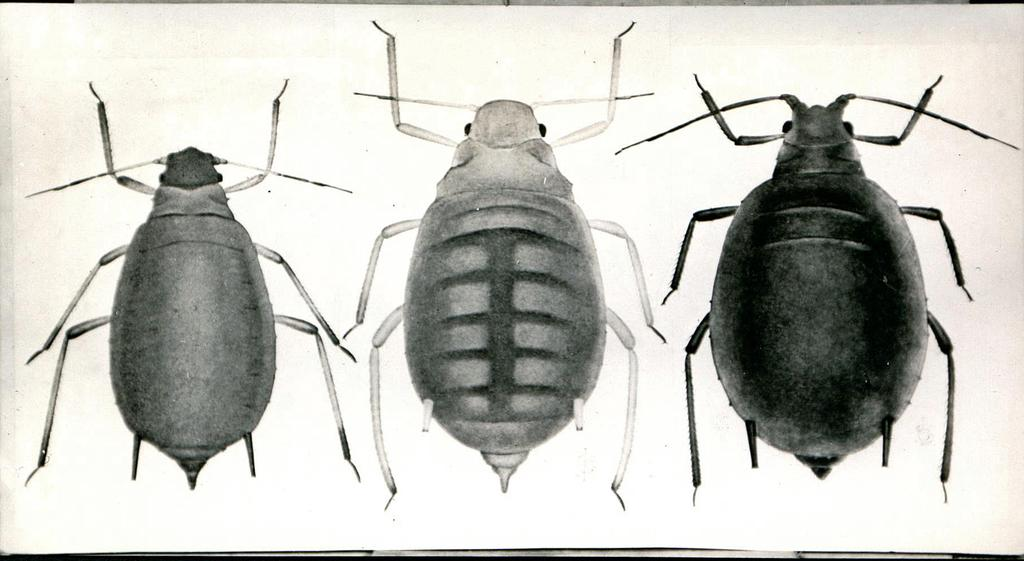What type of insects are shown in the image? There are cockroaches depicted in the image. What religious beliefs do the cockroaches in the image follow? The image does not provide any information about the religious beliefs of the cockroaches, as they are insects and do not have religious beliefs. 